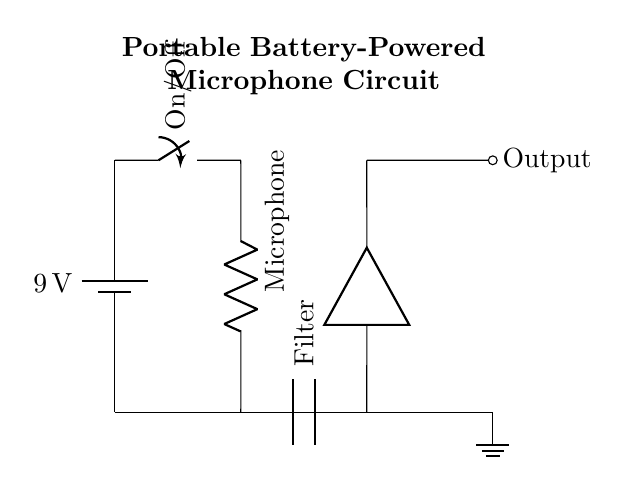What is the voltage of the battery? The circuit shows a 9V battery connected at the top of the circuit diagram. This voltage indicates the potential supplied to the circuit.
Answer: 9 volts What type of switch is used in the circuit? The diagram depicts a switch labeled as On/Off, indicating a simple mechanical switch capable of breaking or completing the circuit.
Answer: On/Off switch How many components are in series in this circuit? The diagram includes five components: a battery, a switch, a microphone (represented by a resistor), a filter capacitor, and an amplifier. All are connected in series from the battery to the output.
Answer: Five What is the purpose of the capacitor in the circuit? The capacitor is labeled as Filter, which suggests its role is to filter out noise and ensure clean audio signals are passed on to the amplifier.
Answer: Noise filtering Which component directly follows the microphone? The drawing shows that the microphone, represented as a resistor, is directly connected to a capacitor for filtering purposes.
Answer: Capacitor What is the output of the circuit? The output is shown as a node labeled Output on the right side of the diagram, indicating where the amplified audio signal would be delivered.
Answer: Output How does the switch affect the circuit operation? The switch can connect or disconnect the circuit from the battery. When closed (On), it allows current to flow; when open (Off), it interrupts current flow, thus stopping the operation of the microphone.
Answer: Controls current flow 